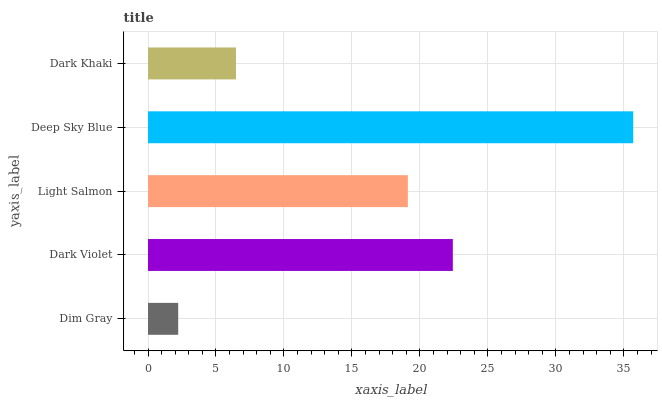Is Dim Gray the minimum?
Answer yes or no. Yes. Is Deep Sky Blue the maximum?
Answer yes or no. Yes. Is Dark Violet the minimum?
Answer yes or no. No. Is Dark Violet the maximum?
Answer yes or no. No. Is Dark Violet greater than Dim Gray?
Answer yes or no. Yes. Is Dim Gray less than Dark Violet?
Answer yes or no. Yes. Is Dim Gray greater than Dark Violet?
Answer yes or no. No. Is Dark Violet less than Dim Gray?
Answer yes or no. No. Is Light Salmon the high median?
Answer yes or no. Yes. Is Light Salmon the low median?
Answer yes or no. Yes. Is Dark Khaki the high median?
Answer yes or no. No. Is Dark Violet the low median?
Answer yes or no. No. 